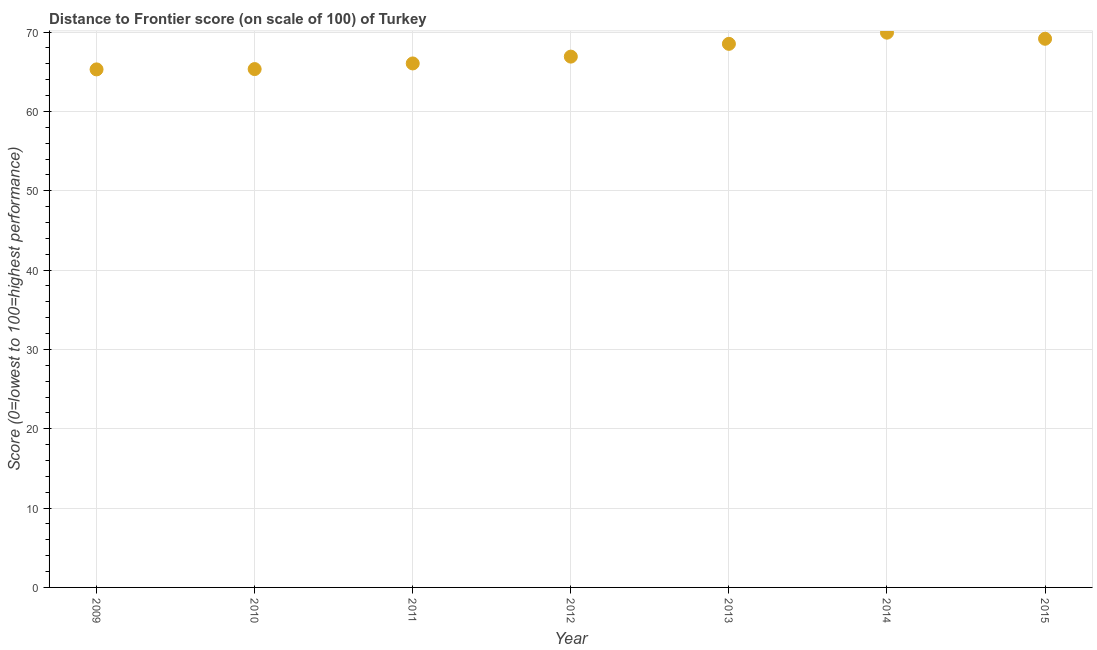What is the distance to frontier score in 2012?
Offer a very short reply. 66.91. Across all years, what is the maximum distance to frontier score?
Your response must be concise. 69.93. Across all years, what is the minimum distance to frontier score?
Provide a short and direct response. 65.3. In which year was the distance to frontier score maximum?
Make the answer very short. 2014. What is the sum of the distance to frontier score?
Make the answer very short. 471.21. What is the difference between the distance to frontier score in 2013 and 2014?
Your answer should be compact. -1.41. What is the average distance to frontier score per year?
Keep it short and to the point. 67.32. What is the median distance to frontier score?
Offer a terse response. 66.91. What is the ratio of the distance to frontier score in 2012 to that in 2013?
Make the answer very short. 0.98. What is the difference between the highest and the second highest distance to frontier score?
Provide a succinct answer. 0.77. Is the sum of the distance to frontier score in 2009 and 2012 greater than the maximum distance to frontier score across all years?
Make the answer very short. Yes. What is the difference between the highest and the lowest distance to frontier score?
Ensure brevity in your answer.  4.63. How many years are there in the graph?
Your answer should be compact. 7. What is the difference between two consecutive major ticks on the Y-axis?
Offer a very short reply. 10. Are the values on the major ticks of Y-axis written in scientific E-notation?
Make the answer very short. No. Does the graph contain any zero values?
Your response must be concise. No. Does the graph contain grids?
Offer a terse response. Yes. What is the title of the graph?
Ensure brevity in your answer.  Distance to Frontier score (on scale of 100) of Turkey. What is the label or title of the Y-axis?
Give a very brief answer. Score (0=lowest to 100=highest performance). What is the Score (0=lowest to 100=highest performance) in 2009?
Give a very brief answer. 65.3. What is the Score (0=lowest to 100=highest performance) in 2010?
Provide a succinct answer. 65.34. What is the Score (0=lowest to 100=highest performance) in 2011?
Provide a succinct answer. 66.05. What is the Score (0=lowest to 100=highest performance) in 2012?
Provide a succinct answer. 66.91. What is the Score (0=lowest to 100=highest performance) in 2013?
Offer a terse response. 68.52. What is the Score (0=lowest to 100=highest performance) in 2014?
Your answer should be very brief. 69.93. What is the Score (0=lowest to 100=highest performance) in 2015?
Provide a short and direct response. 69.16. What is the difference between the Score (0=lowest to 100=highest performance) in 2009 and 2010?
Give a very brief answer. -0.04. What is the difference between the Score (0=lowest to 100=highest performance) in 2009 and 2011?
Make the answer very short. -0.75. What is the difference between the Score (0=lowest to 100=highest performance) in 2009 and 2012?
Offer a very short reply. -1.61. What is the difference between the Score (0=lowest to 100=highest performance) in 2009 and 2013?
Provide a succinct answer. -3.22. What is the difference between the Score (0=lowest to 100=highest performance) in 2009 and 2014?
Your response must be concise. -4.63. What is the difference between the Score (0=lowest to 100=highest performance) in 2009 and 2015?
Offer a terse response. -3.86. What is the difference between the Score (0=lowest to 100=highest performance) in 2010 and 2011?
Make the answer very short. -0.71. What is the difference between the Score (0=lowest to 100=highest performance) in 2010 and 2012?
Give a very brief answer. -1.57. What is the difference between the Score (0=lowest to 100=highest performance) in 2010 and 2013?
Your response must be concise. -3.18. What is the difference between the Score (0=lowest to 100=highest performance) in 2010 and 2014?
Give a very brief answer. -4.59. What is the difference between the Score (0=lowest to 100=highest performance) in 2010 and 2015?
Offer a terse response. -3.82. What is the difference between the Score (0=lowest to 100=highest performance) in 2011 and 2012?
Offer a very short reply. -0.86. What is the difference between the Score (0=lowest to 100=highest performance) in 2011 and 2013?
Offer a very short reply. -2.47. What is the difference between the Score (0=lowest to 100=highest performance) in 2011 and 2014?
Give a very brief answer. -3.88. What is the difference between the Score (0=lowest to 100=highest performance) in 2011 and 2015?
Your answer should be compact. -3.11. What is the difference between the Score (0=lowest to 100=highest performance) in 2012 and 2013?
Provide a succinct answer. -1.61. What is the difference between the Score (0=lowest to 100=highest performance) in 2012 and 2014?
Provide a short and direct response. -3.02. What is the difference between the Score (0=lowest to 100=highest performance) in 2012 and 2015?
Your response must be concise. -2.25. What is the difference between the Score (0=lowest to 100=highest performance) in 2013 and 2014?
Your answer should be very brief. -1.41. What is the difference between the Score (0=lowest to 100=highest performance) in 2013 and 2015?
Provide a succinct answer. -0.64. What is the difference between the Score (0=lowest to 100=highest performance) in 2014 and 2015?
Provide a short and direct response. 0.77. What is the ratio of the Score (0=lowest to 100=highest performance) in 2009 to that in 2010?
Give a very brief answer. 1. What is the ratio of the Score (0=lowest to 100=highest performance) in 2009 to that in 2011?
Your response must be concise. 0.99. What is the ratio of the Score (0=lowest to 100=highest performance) in 2009 to that in 2012?
Provide a succinct answer. 0.98. What is the ratio of the Score (0=lowest to 100=highest performance) in 2009 to that in 2013?
Give a very brief answer. 0.95. What is the ratio of the Score (0=lowest to 100=highest performance) in 2009 to that in 2014?
Offer a terse response. 0.93. What is the ratio of the Score (0=lowest to 100=highest performance) in 2009 to that in 2015?
Make the answer very short. 0.94. What is the ratio of the Score (0=lowest to 100=highest performance) in 2010 to that in 2013?
Provide a succinct answer. 0.95. What is the ratio of the Score (0=lowest to 100=highest performance) in 2010 to that in 2014?
Your response must be concise. 0.93. What is the ratio of the Score (0=lowest to 100=highest performance) in 2010 to that in 2015?
Your answer should be very brief. 0.94. What is the ratio of the Score (0=lowest to 100=highest performance) in 2011 to that in 2012?
Your answer should be very brief. 0.99. What is the ratio of the Score (0=lowest to 100=highest performance) in 2011 to that in 2014?
Give a very brief answer. 0.94. What is the ratio of the Score (0=lowest to 100=highest performance) in 2011 to that in 2015?
Make the answer very short. 0.95. What is the ratio of the Score (0=lowest to 100=highest performance) in 2012 to that in 2014?
Your response must be concise. 0.96. What is the ratio of the Score (0=lowest to 100=highest performance) in 2013 to that in 2015?
Provide a succinct answer. 0.99. 